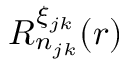Convert formula to latex. <formula><loc_0><loc_0><loc_500><loc_500>R _ { n _ { j k } } ^ { \xi _ { j k } } ( r )</formula> 